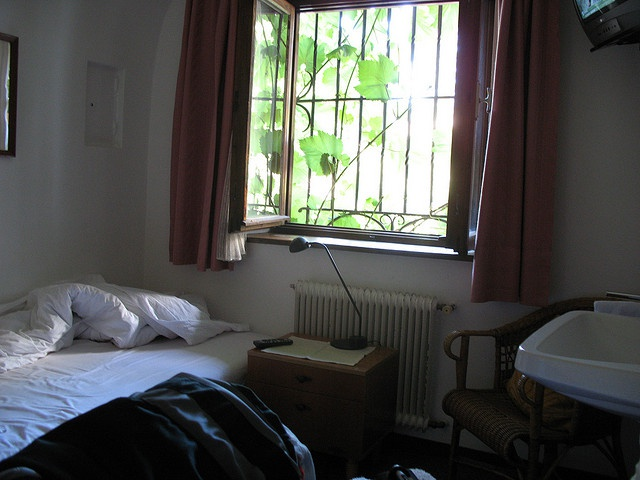Describe the objects in this image and their specific colors. I can see bed in black, gray, and darkgray tones, chair in black, gray, and purple tones, sink in black and purple tones, tv in black and teal tones, and remote in black tones in this image. 